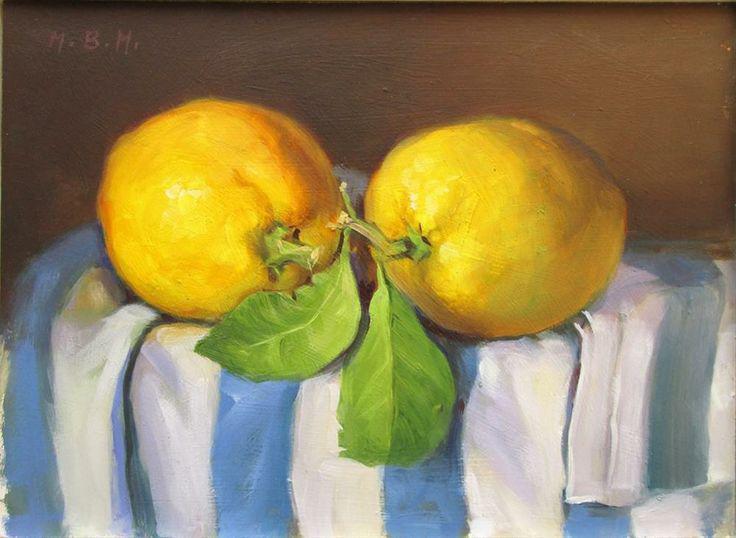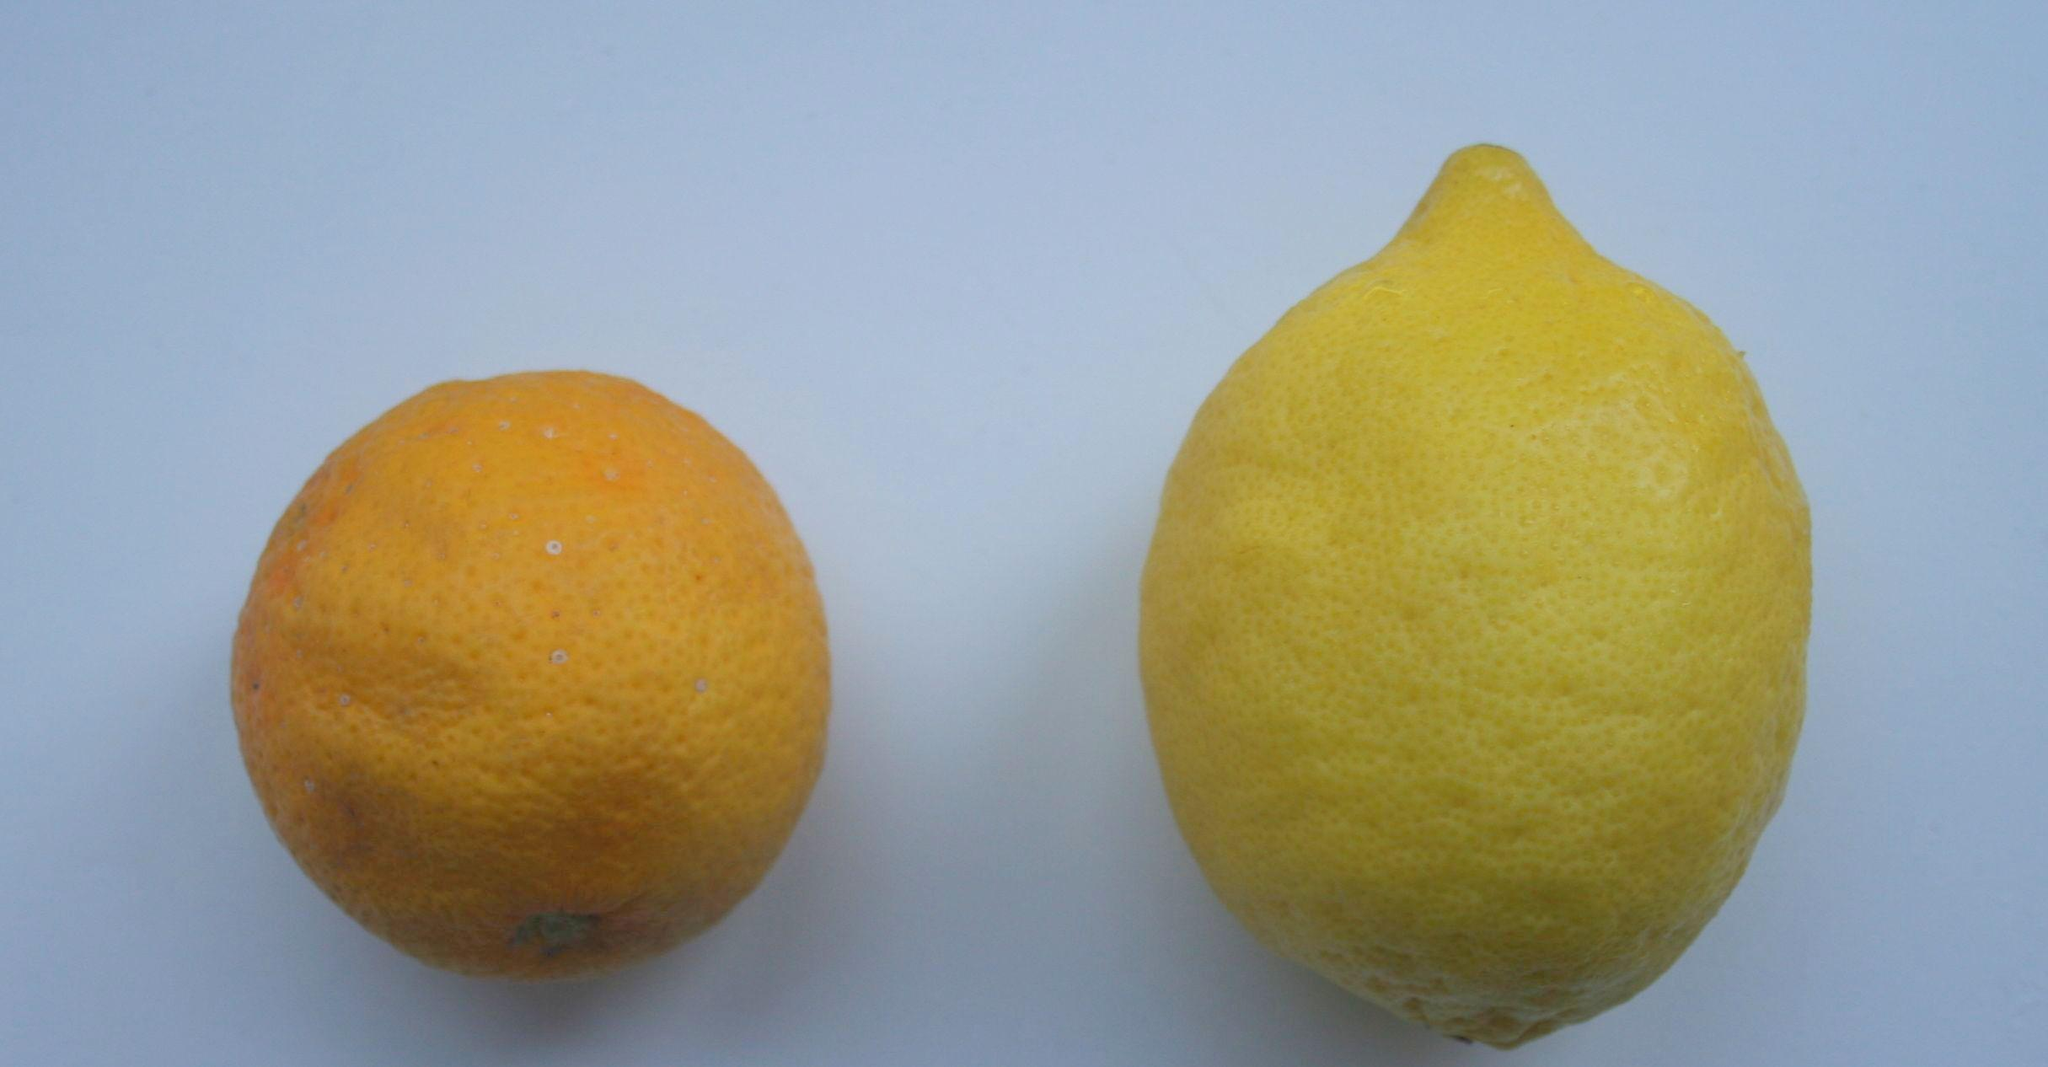The first image is the image on the left, the second image is the image on the right. Analyze the images presented: Is the assertion "All of the lemons are connected to the same branch" valid? Answer yes or no. No. The first image is the image on the left, the second image is the image on the right. Analyze the images presented: Is the assertion "Each image contains exactly two whole lemons, and the lefthand image shows lemons joined with a piece of branch and leaves intact, sitting on a surface." valid? Answer yes or no. Yes. 